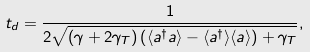<formula> <loc_0><loc_0><loc_500><loc_500>t _ { d } = \frac { 1 } { 2 \sqrt { ( \gamma + 2 \gamma _ { T } ) \left ( \langle a ^ { \dagger } a \rangle - \langle a ^ { \dagger } \rangle \langle a \rangle \right ) + \gamma _ { T } } } ,</formula> 